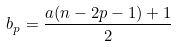<formula> <loc_0><loc_0><loc_500><loc_500>b _ { p } = \frac { a ( n - 2 p - 1 ) + 1 } { 2 }</formula> 